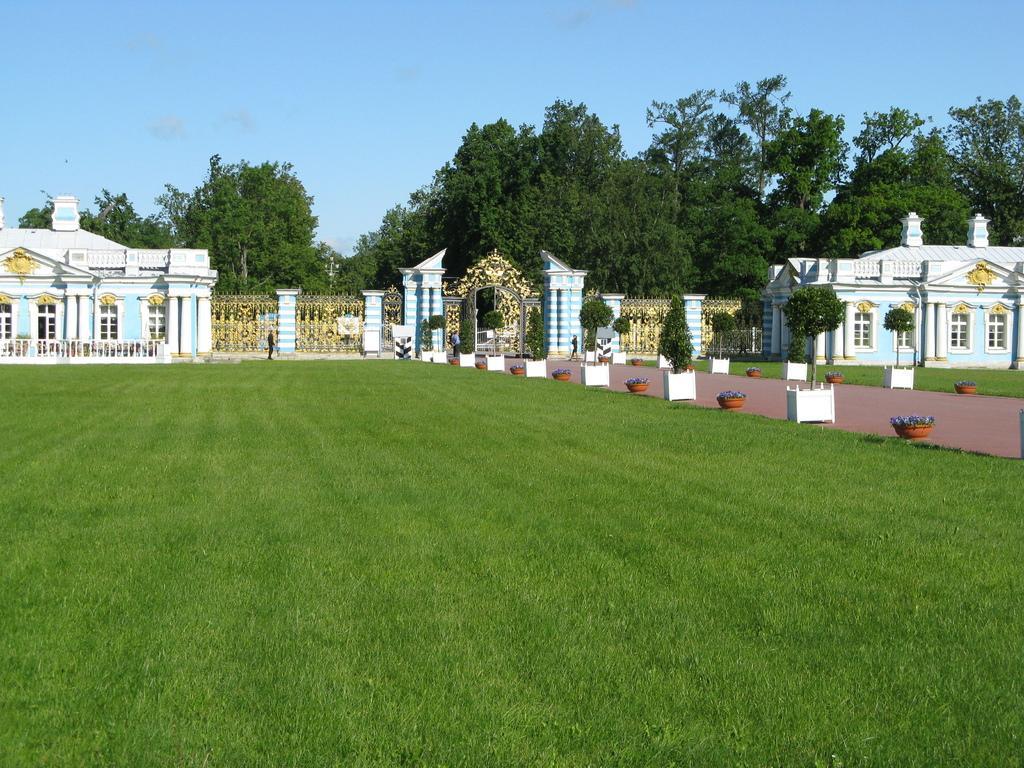In one or two sentences, can you explain what this image depicts? In the foreground of the picture there is grass. In the center of the picture there are trees, buildings, railing, gate, plants, flower pots and grass. It is sunny. 